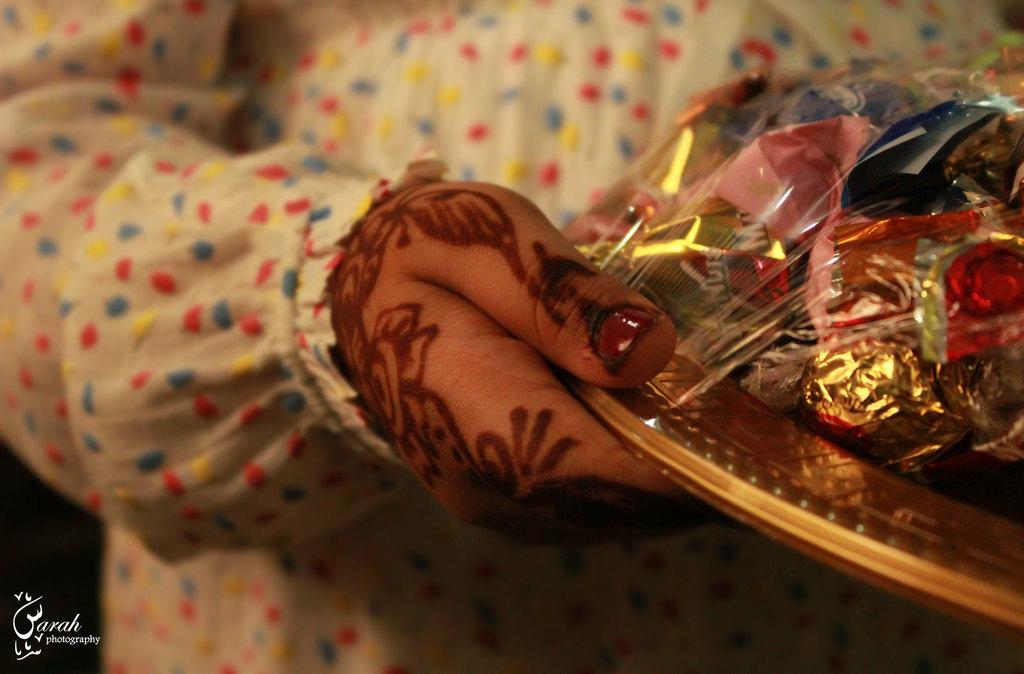What is the person in the image holding? The person is holding an object in the image. Can you describe the person's appearance in the image? The person is partially covered. Is there any text or logo visible in the image? Yes, there is a watermark in the bottom left corner of the image. What can be said about the lighting in the image? The background of the image is dark. What type of drum can be heard in the image? There is no drum present in the image, and therefore no sound can be heard. What acoustics can be observed in the brick building in the image? There is no brick building present in the image, and therefore no acoustics can be observed. 